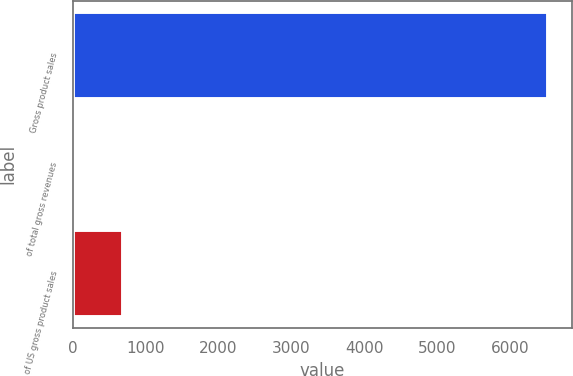<chart> <loc_0><loc_0><loc_500><loc_500><bar_chart><fcel>Gross product sales<fcel>of total gross revenues<fcel>of US gross product sales<nl><fcel>6523<fcel>35<fcel>683.8<nl></chart> 